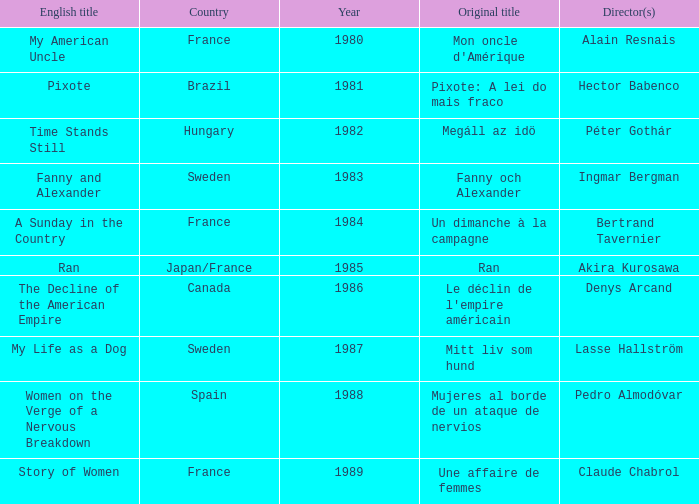What's the English Title of Fanny Och Alexander? Fanny and Alexander. 